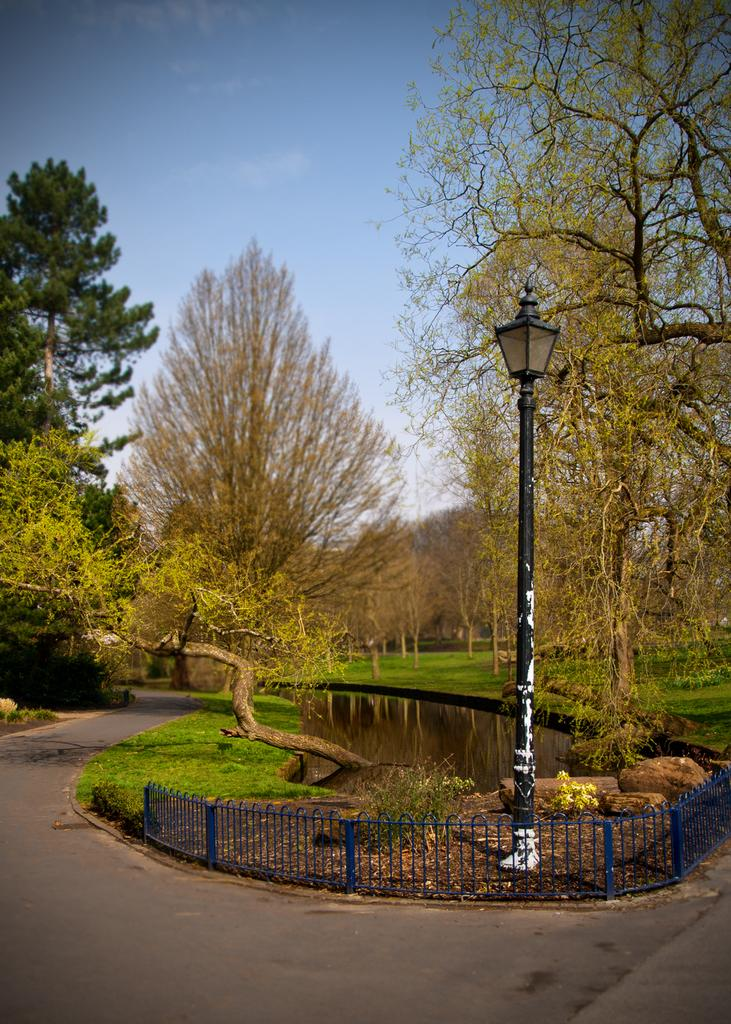What type of vegetation is present in the image? There are many trees in the image. What is located at the bottom of the image? There is a road at the bottom of the image. What can be seen in the middle of the image? There is water and fencing in the middle of the image. What is present in the front of the image? There is a pole in the front of the image. What is visible at the top of the image? The sky is visible at the top of the image. How many bats are hanging from the trees in the image? There are no bats present in the image; it only features trees, a road, water, fencing, a pole, and the sky. What type of cloud is visible in the image? There is no cloud visible in the image; only the sky is present at the top of the image. 